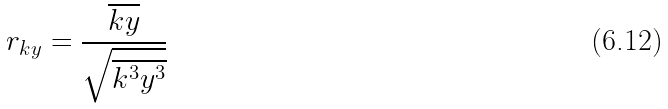<formula> <loc_0><loc_0><loc_500><loc_500>r _ { k y } = \frac { \overline { k y } } { \sqrt { \overline { k ^ { 3 } } \overline { y ^ { 3 } } } }</formula> 